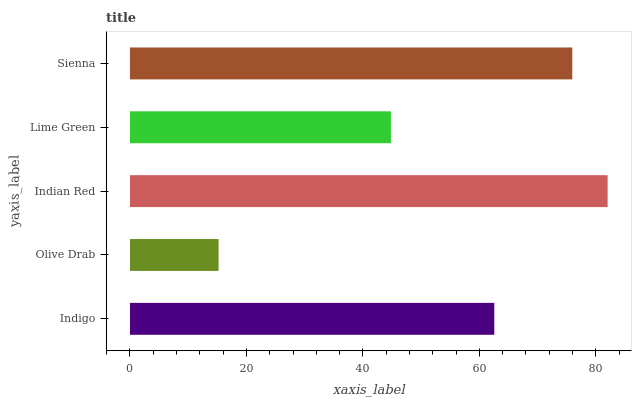Is Olive Drab the minimum?
Answer yes or no. Yes. Is Indian Red the maximum?
Answer yes or no. Yes. Is Indian Red the minimum?
Answer yes or no. No. Is Olive Drab the maximum?
Answer yes or no. No. Is Indian Red greater than Olive Drab?
Answer yes or no. Yes. Is Olive Drab less than Indian Red?
Answer yes or no. Yes. Is Olive Drab greater than Indian Red?
Answer yes or no. No. Is Indian Red less than Olive Drab?
Answer yes or no. No. Is Indigo the high median?
Answer yes or no. Yes. Is Indigo the low median?
Answer yes or no. Yes. Is Sienna the high median?
Answer yes or no. No. Is Olive Drab the low median?
Answer yes or no. No. 